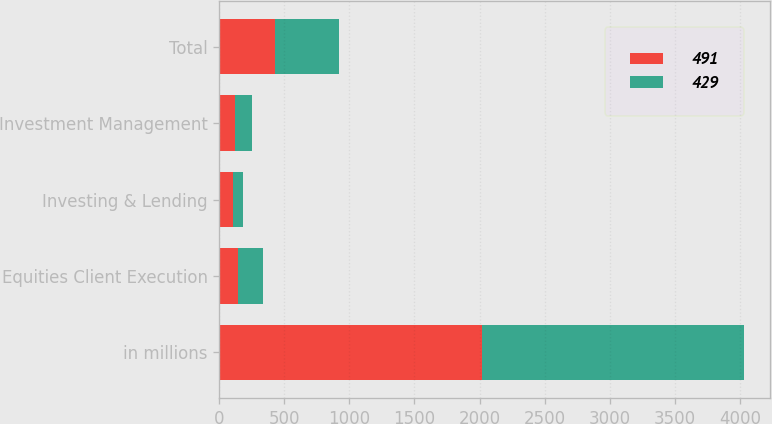Convert chart to OTSL. <chart><loc_0><loc_0><loc_500><loc_500><stacked_bar_chart><ecel><fcel>in millions<fcel>Equities Client Execution<fcel>Investing & Lending<fcel>Investment Management<fcel>Total<nl><fcel>491<fcel>2016<fcel>141<fcel>105<fcel>118<fcel>429<nl><fcel>429<fcel>2015<fcel>193<fcel>75<fcel>131<fcel>491<nl></chart> 